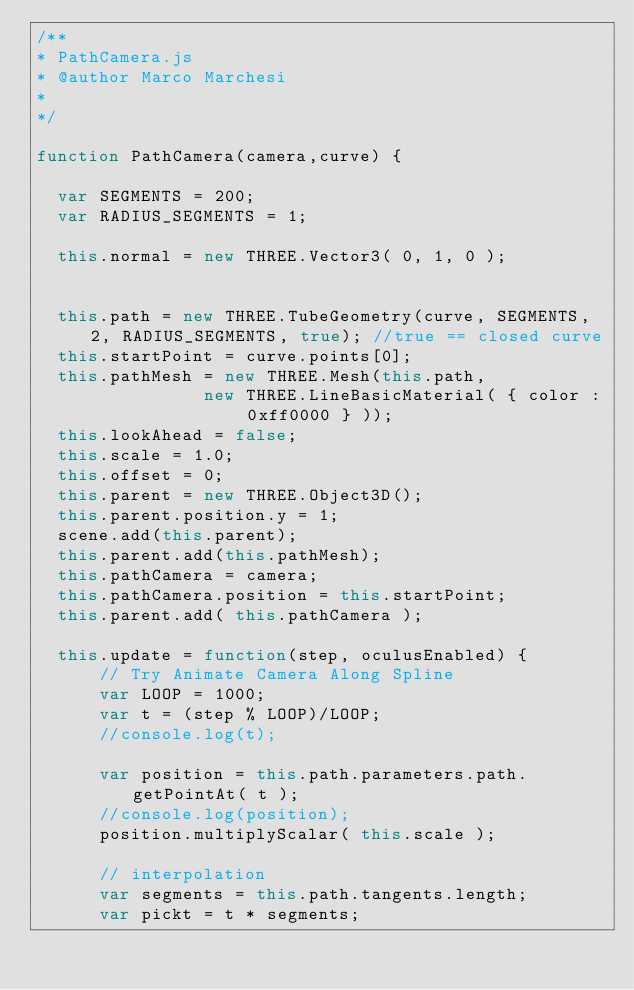Convert code to text. <code><loc_0><loc_0><loc_500><loc_500><_JavaScript_>/**
* PathCamera.js
* @author Marco Marchesi
*
*/

function PathCamera(camera,curve) {

  var SEGMENTS = 200;
  var RADIUS_SEGMENTS = 1;

  this.normal = new THREE.Vector3( 0, 1, 0 );


  this.path = new THREE.TubeGeometry(curve, SEGMENTS, 2, RADIUS_SEGMENTS, true); //true == closed curve
  this.startPoint = curve.points[0];
  this.pathMesh = new THREE.Mesh(this.path,
                new THREE.LineBasicMaterial( { color : 0xff0000 } ));
  this.lookAhead = false;
  this.scale = 1.0;
  this.offset = 0;
  this.parent = new THREE.Object3D();
  this.parent.position.y = 1;
  scene.add(this.parent);
  this.parent.add(this.pathMesh);
  this.pathCamera = camera;
  this.pathCamera.position = this.startPoint;
  this.parent.add( this.pathCamera );

  this.update = function(step, oculusEnabled) {
      // Try Animate Camera Along Spline
      var LOOP = 1000;
      var t = (step % LOOP)/LOOP;
      //console.log(t);

      var position = this.path.parameters.path.getPointAt( t );
      //console.log(position);
      position.multiplyScalar( this.scale );

      // interpolation
      var segments = this.path.tangents.length;
      var pickt = t * segments;</code> 